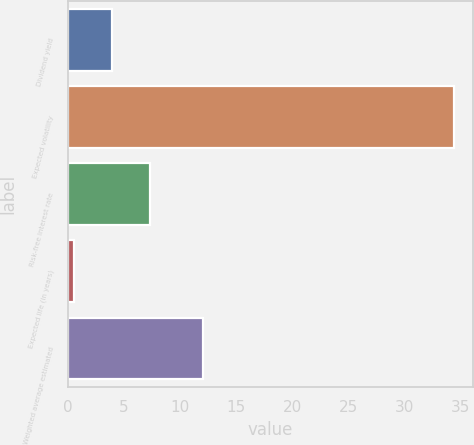Convert chart. <chart><loc_0><loc_0><loc_500><loc_500><bar_chart><fcel>Dividend yield<fcel>Expected volatility<fcel>Risk-free interest rate<fcel>Expected life (in years)<fcel>Weighted average estimated<nl><fcel>3.89<fcel>34.4<fcel>7.28<fcel>0.5<fcel>12.02<nl></chart> 